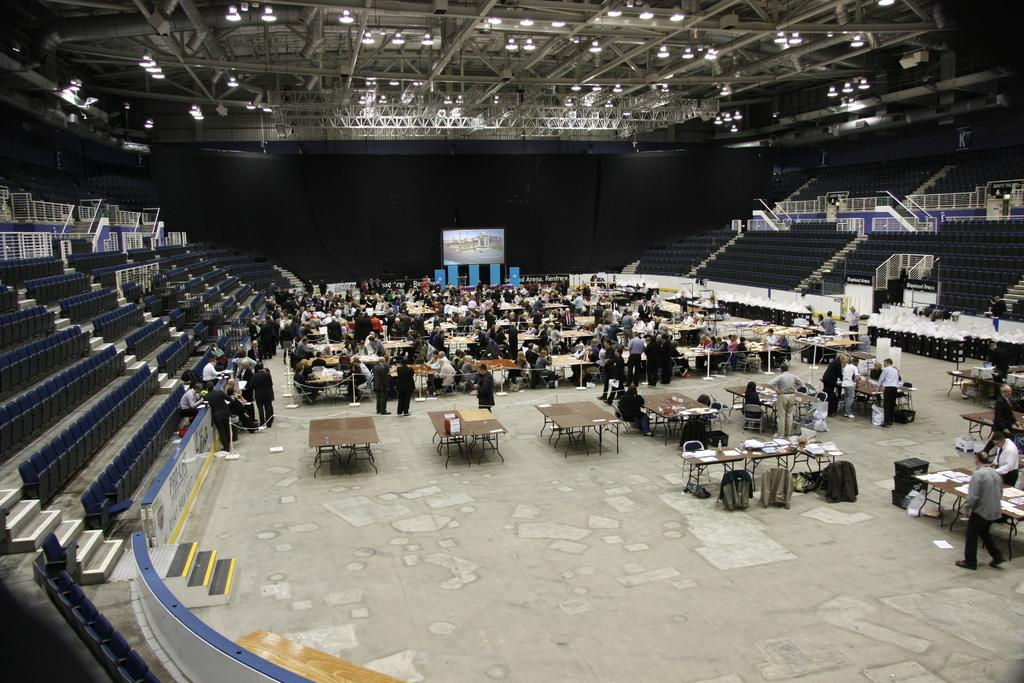How many people are present in the image? There are many people in the image. What type of furniture is visible in the image? There are chairs and tables in the image. What can be found on the tables in the image? There are various items on the tables. What can be seen in the background of the image? In the background, there are chairs, stairs, and lights. What type of glue is being used by the person in the image? There is no glue present in the image, and no one is using glue. Can you tell me the total cost of the items on the receipt in the image? There is no receipt present in the image, so the total cost of the items cannot be determined. 